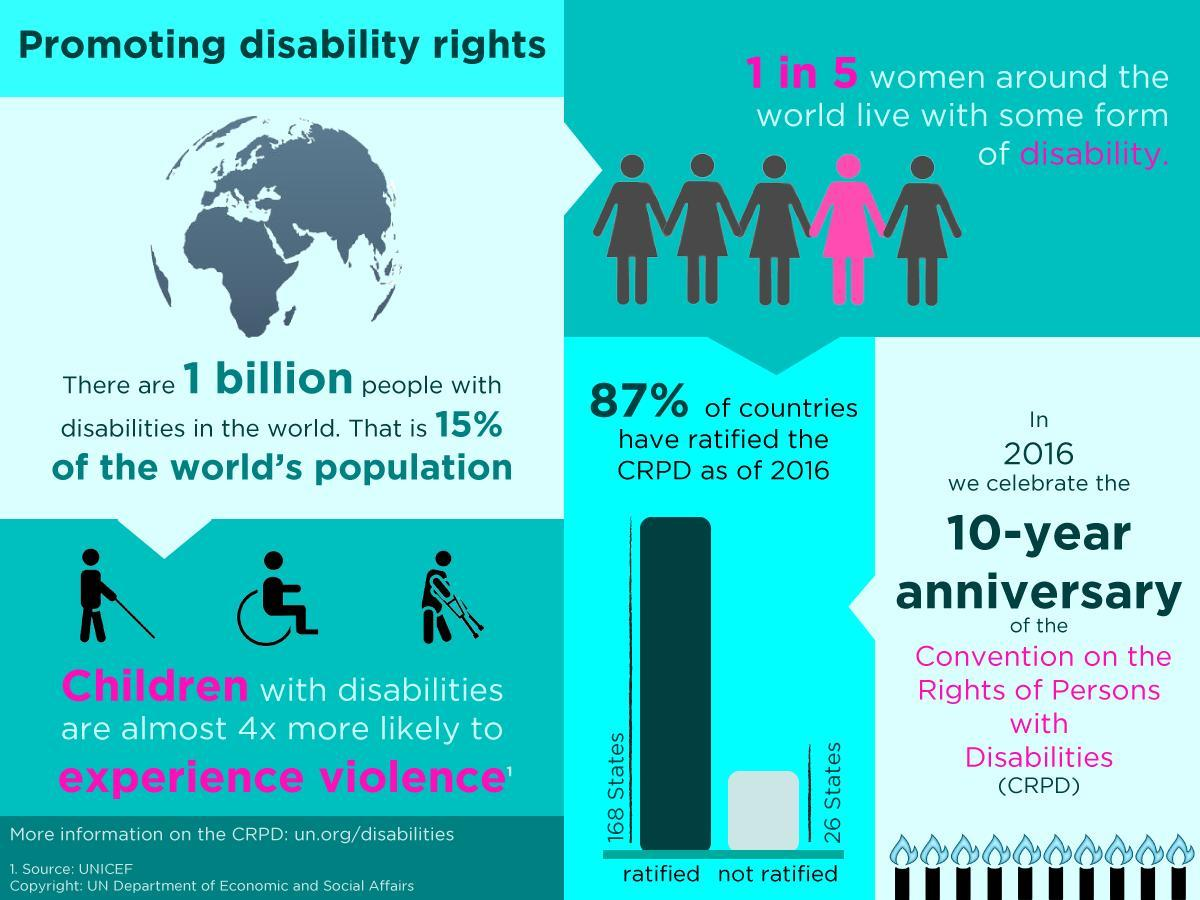What percent of countries have not ratified CPRD as of 2016?
Answer the question with a short phrase. 13% 